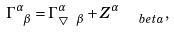<formula> <loc_0><loc_0><loc_500><loc_500>\Gamma _ { \ \beta } ^ { \alpha } = \Gamma _ { \bigtriangledown \ \beta } ^ { \alpha } + Z _ { \quad b e t a } ^ { \alpha } ,</formula> 